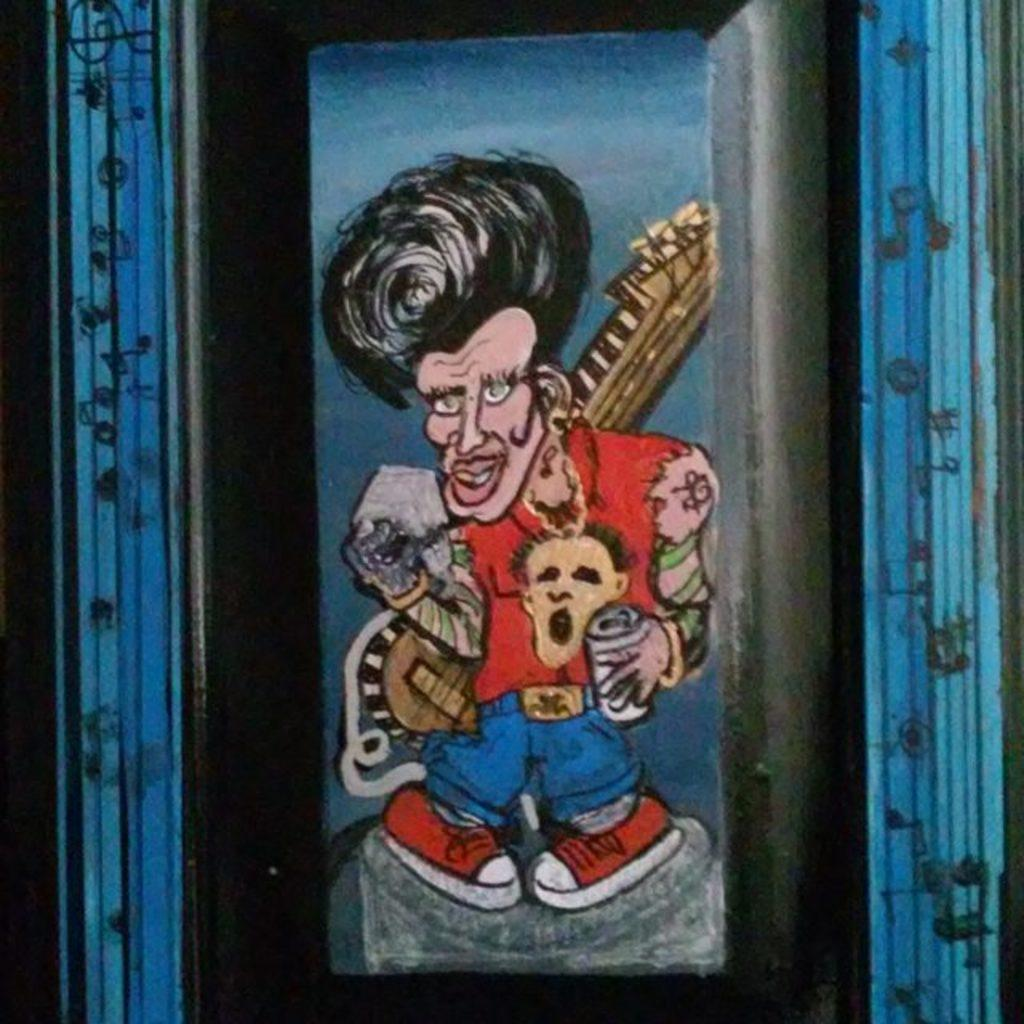What is the main subject of the image? The main subject of the image is a man. What is the man holding in the image? The man is holding a guitar. Can you tell me how many bird nests are visible in the image? There are no bird nests visible in the image; it features a man holding a guitar. What type of expert is the man talking to in the image? There is no expert or conversation present in the image; it only shows a man holding a guitar. 